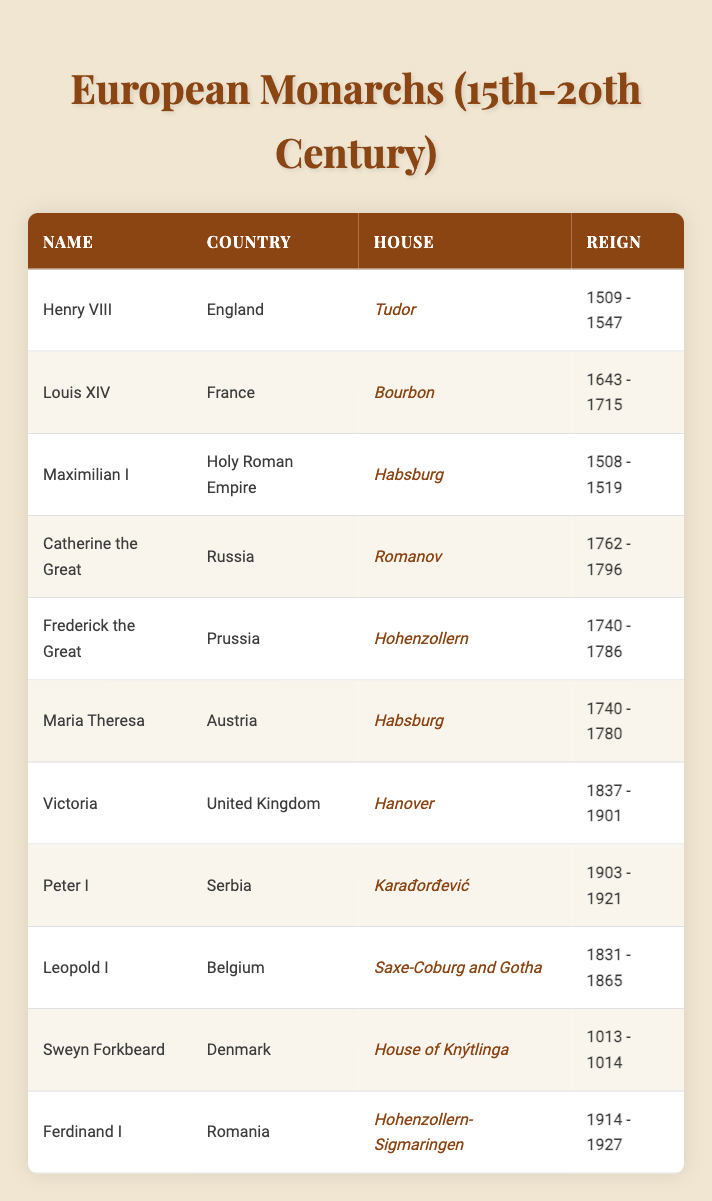What is the reign period of Louis XIV? The reign period of Louis XIV is listed in the table as 1643 - 1715, which can be directly found in the "Reign" column next to his name.
Answer: 1643 - 1715 Who was the monarch of Austria during the years 1740 to 1780? The table shows that Maria Theresa was the monarch of Austria during the reign period of 1740 to 1780. This can be confirmed by looking at the corresponding row that matches these reign dates.
Answer: Maria Theresa Which monarch ruled the longest during the 15th to 20th centuries? To find the longest reign, we need to compare the lengths of reign for each monarch listed. The longest reign belongs to Louis XIV from 1643 to 1715, which is a total of 72 years. Other reigns, such as Victoria’s (1837 - 1901, 63 years) and Frederick the Great’s (1740 - 1786, 46 years), are shorter.
Answer: Louis XIV Is Frederick the Great part of the Hohenzollern house? The table indicates that Frederick the Great is indeed part of the Hohenzollern house, which is clearly stated next to his name in the "House" column.
Answer: Yes How many monarchs reigned prior to the 19th century? By reviewing the table, we count the monarchs who reigned before 1800, which are Henry VIII, Louis XIV, Maximilian I, Catherine the Great, Frederick the Great, and Maria Theresa. There are 6 such monarchs in total.
Answer: 6 What was the reign period of Peter I, and how does it compare with Ferdinand I’s reign period? Peter I ruled from 1903 to 1921, while Ferdinand I reigned from 1914 to 1927. Peter I's reign lasted for 18 years, and Ferdinand I's reign lasted for 13 years. Although both reigns overlapped from 1914 to 1921, Peter I had a longer overall reign period compared to Ferdinand I.
Answer: Peter I: 1903 - 1921, Ferdinand I: 1914 - 1927, Peter I reigned longer Which countries had monarchs from the Habsburg house, and what were their reign periods? The table reveals that both Maximilian I and Maria Theresa were from the Habsburg house. Maximilian I reigned from 1508 to 1519, while Maria Theresa reigned from 1740 to 1780. Thus, these are the monarchs from the Habsburg house and their respective reign periods.
Answer: Maximilian I: 1508 - 1519, Maria Theresa: 1740 - 1780 Did any monarchs in the table rule in the 20th century? Upon examining the table, both Peter I of Serbia and Ferdinand I of Romania are confirmed as rulers in the 20th century, with their reign periods noted from 1903 - 1921 and 1914 - 1927, respectively.
Answer: Yes How many years did Louis XIV rule longer than Henry VIII? Louis XIV ruled from 1643 to 1715 (72 years), while Henry VIII ruled from 1509 to 1547 (38 years). The difference in their reign durations is 72 - 38 = 34 years. Thus, Louis XIV ruled 34 years longer than Henry VIII.
Answer: 34 years 